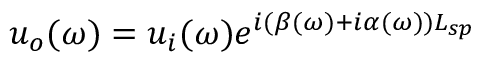<formula> <loc_0><loc_0><loc_500><loc_500>u _ { o } ( \omega ) = u _ { i } ( \omega ) e ^ { i ( \beta ( \omega ) + i \alpha ( \omega ) ) L _ { s p } }</formula> 